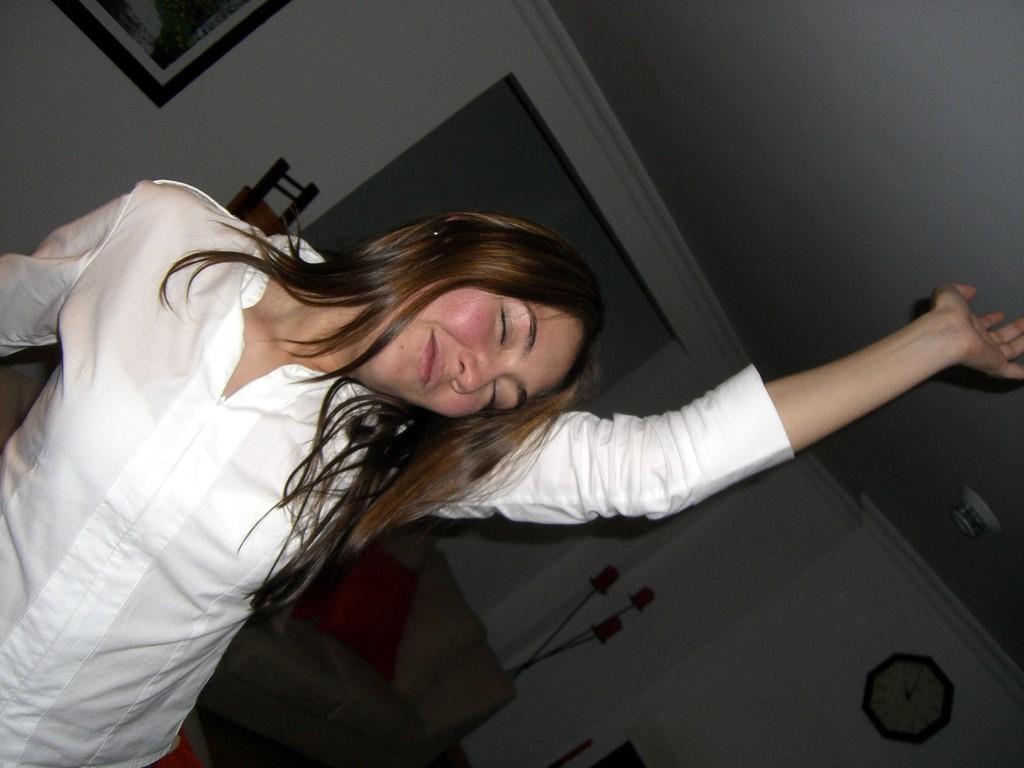Describe this image in one or two sentences. In this picture there is a woman wearing white dress and dancing and there are some other objects in the background. 